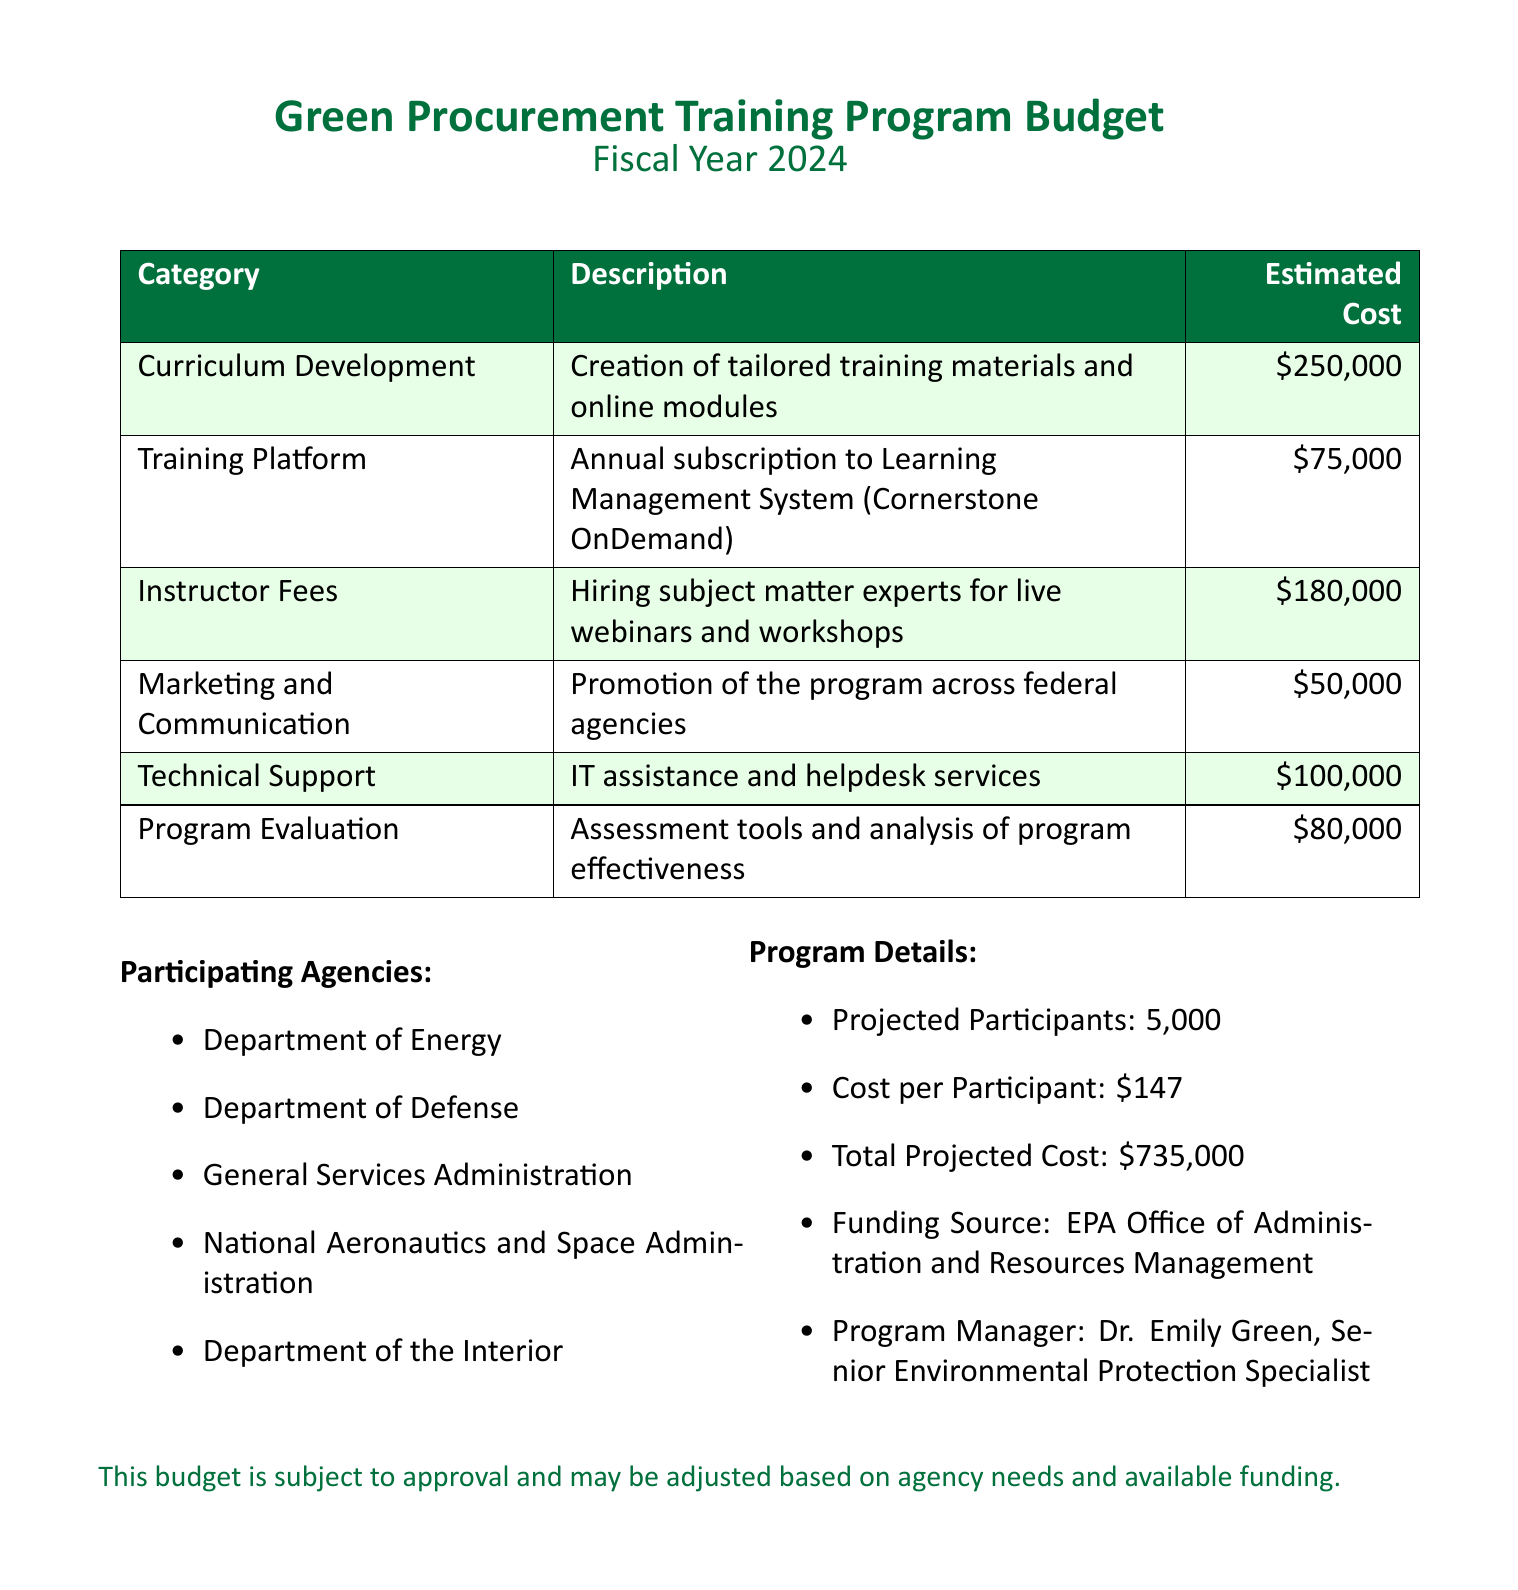What is the total projected cost? The total projected cost is explicitly stated in the document as the sum of estimated costs for all categories, which equals $735,000.
Answer: $735,000 Who is the program manager? The program manager's name is listed in the document, specifically as Dr. Emily Green.
Answer: Dr. Emily Green What is the cost per participant? The cost per participant is detailed as a single figure in the budget section, which is $147.
Answer: $147 How much is allocated for curriculum development? The document specifies the estimated cost for curriculum development as a separate line item, which is $250,000.
Answer: $250,000 Which agency is not participating in the program? The participant agencies are listed in the document, and any agency not mentioned can be inferred as not participating; for example, the Department of Agriculture.
Answer: Department of Agriculture What is the estimated cost for the training platform? The budget details the estimated cost for the training platform as $75,000, which is a specific line item.
Answer: $75,000 How many projected participants are expected? The document states a single number regarding the projected participants, which is 5,000.
Answer: 5,000 What is the total estimated cost for technical support? The estimated cost for technical support is explicitly mentioned in the budget, set at $100,000.
Answer: $100,000 What kind of assistance is included in the budget for technical support? Technical support in the document is described specifically as IT assistance and helpdesk services.
Answer: IT assistance and helpdesk services 